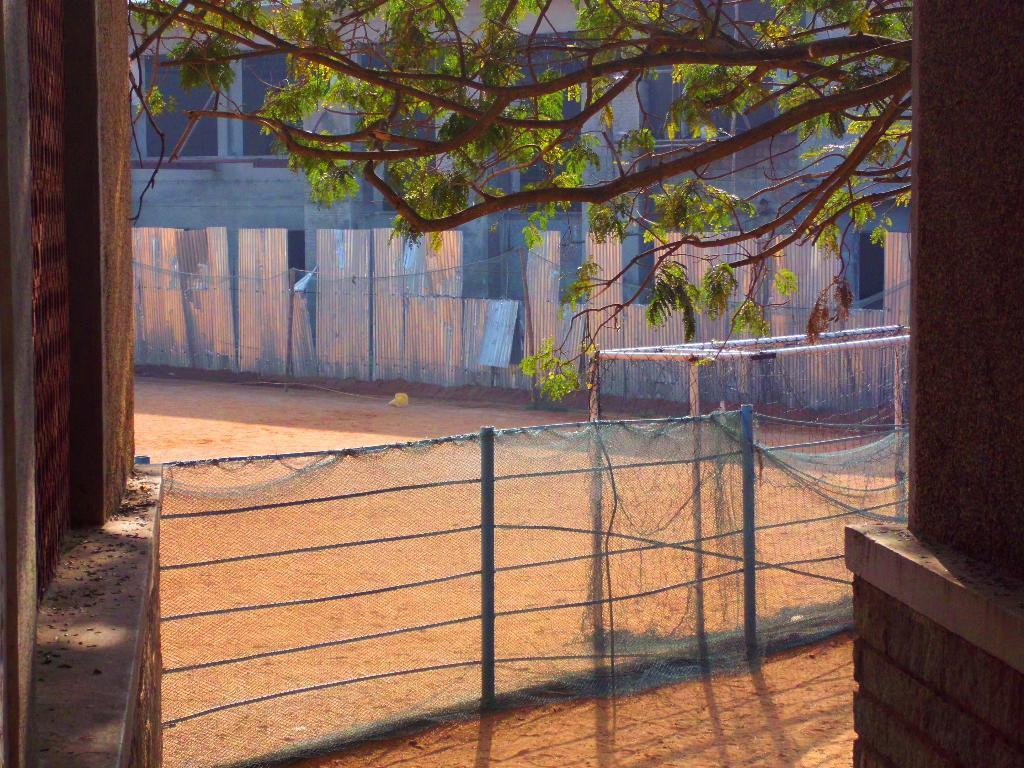What is located in the front of the image? There is a fencing net in the front of the image. What color is the shed visible in the image? The shed is silver-colored. What can be seen in the background of the image? There is a building in the background of the image. Where is the tree located in the image? The tree is in the right corner of the image. What type of eggs can be seen hanging from the tree in the image? There are no eggs present in the image, and the tree does not have any hanging from it. What part of the tree is made of flesh in the image? There is no part of the tree made of flesh in the image, as trees are composed of wood and other plant materials. 